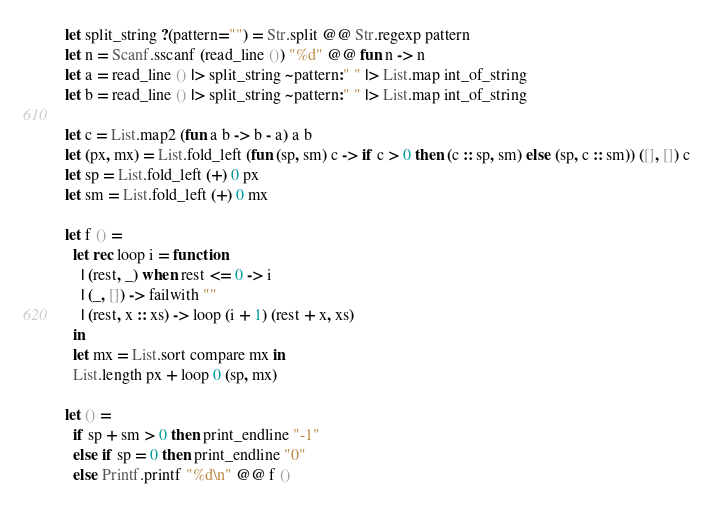Convert code to text. <code><loc_0><loc_0><loc_500><loc_500><_OCaml_>let split_string ?(pattern="") = Str.split @@ Str.regexp pattern
let n = Scanf.sscanf (read_line ()) "%d" @@ fun n -> n
let a = read_line () |> split_string ~pattern:" " |> List.map int_of_string
let b = read_line () |> split_string ~pattern:" " |> List.map int_of_string

let c = List.map2 (fun a b -> b - a) a b
let (px, mx) = List.fold_left (fun (sp, sm) c -> if c > 0 then (c :: sp, sm) else (sp, c :: sm)) ([], []) c
let sp = List.fold_left (+) 0 px
let sm = List.fold_left (+) 0 mx

let f () = 
  let rec loop i = function
    | (rest, _) when rest <= 0 -> i
    | (_, []) -> failwith ""
    | (rest, x :: xs) -> loop (i + 1) (rest + x, xs)
  in
  let mx = List.sort compare mx in
  List.length px + loop 0 (sp, mx)

let () = 
  if sp + sm > 0 then print_endline "-1"
  else if sp = 0 then print_endline "0" 
  else Printf.printf "%d\n" @@ f ()</code> 